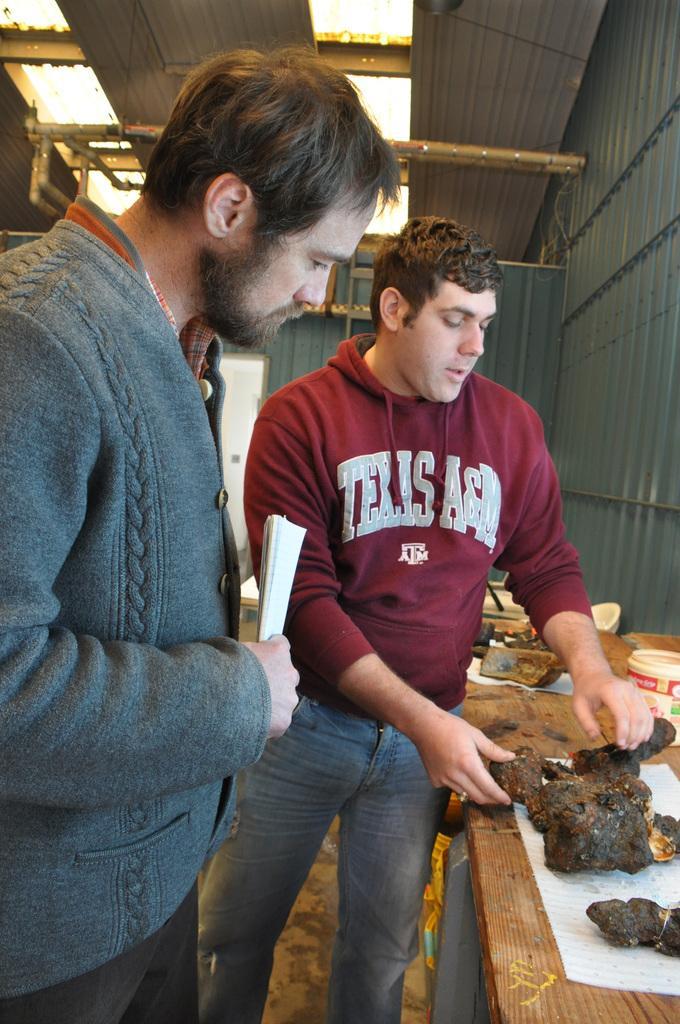How would you summarize this image in a sentence or two? In this image we can see two persons standing, among them one person is holding the papers and the other one is holding some food, we can see some objects on the table, at the top of the roof we can see some metal rods and roof sheets, also we can see the wall. 